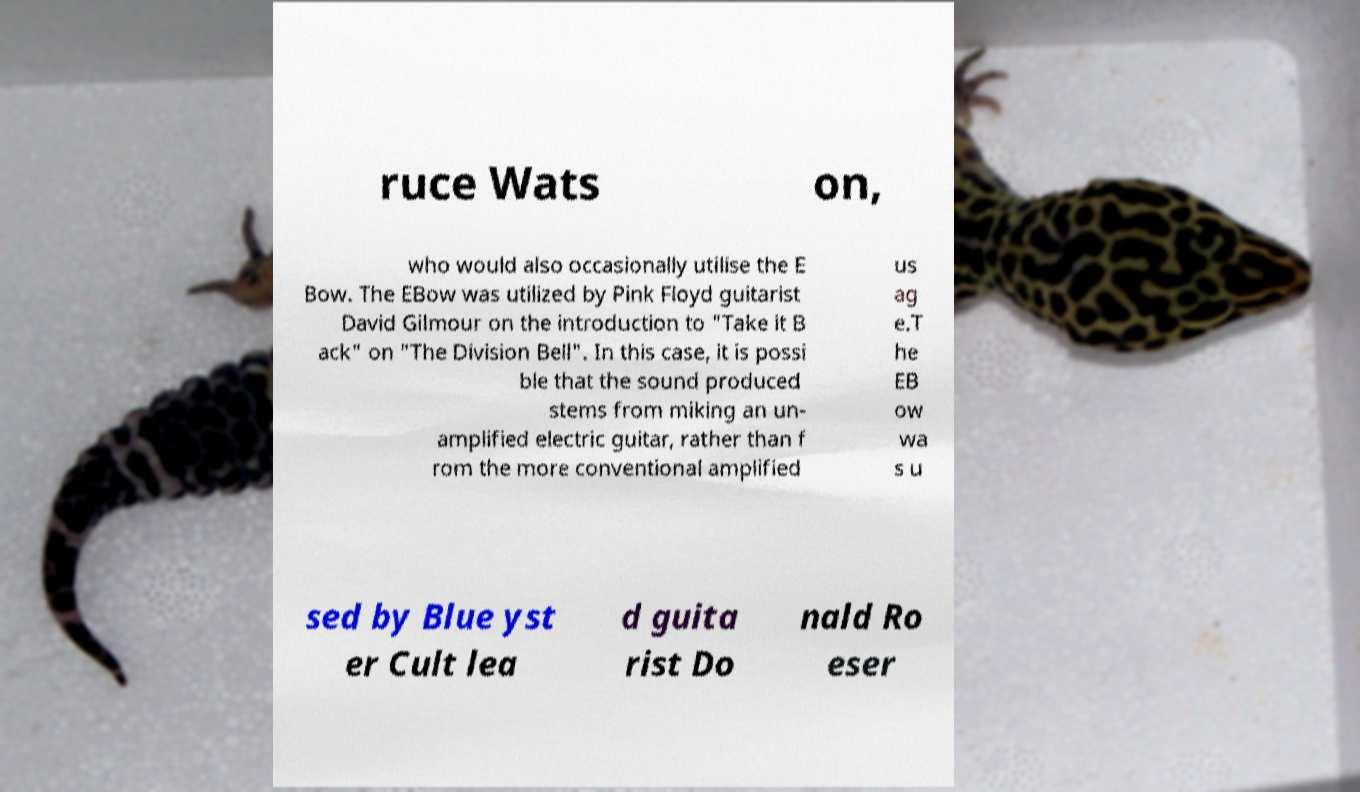Could you extract and type out the text from this image? ruce Wats on, who would also occasionally utilise the E Bow. The EBow was utilized by Pink Floyd guitarist David Gilmour on the introduction to "Take it B ack" on "The Division Bell". In this case, it is possi ble that the sound produced stems from miking an un- amplified electric guitar, rather than f rom the more conventional amplified us ag e.T he EB ow wa s u sed by Blue yst er Cult lea d guita rist Do nald Ro eser 